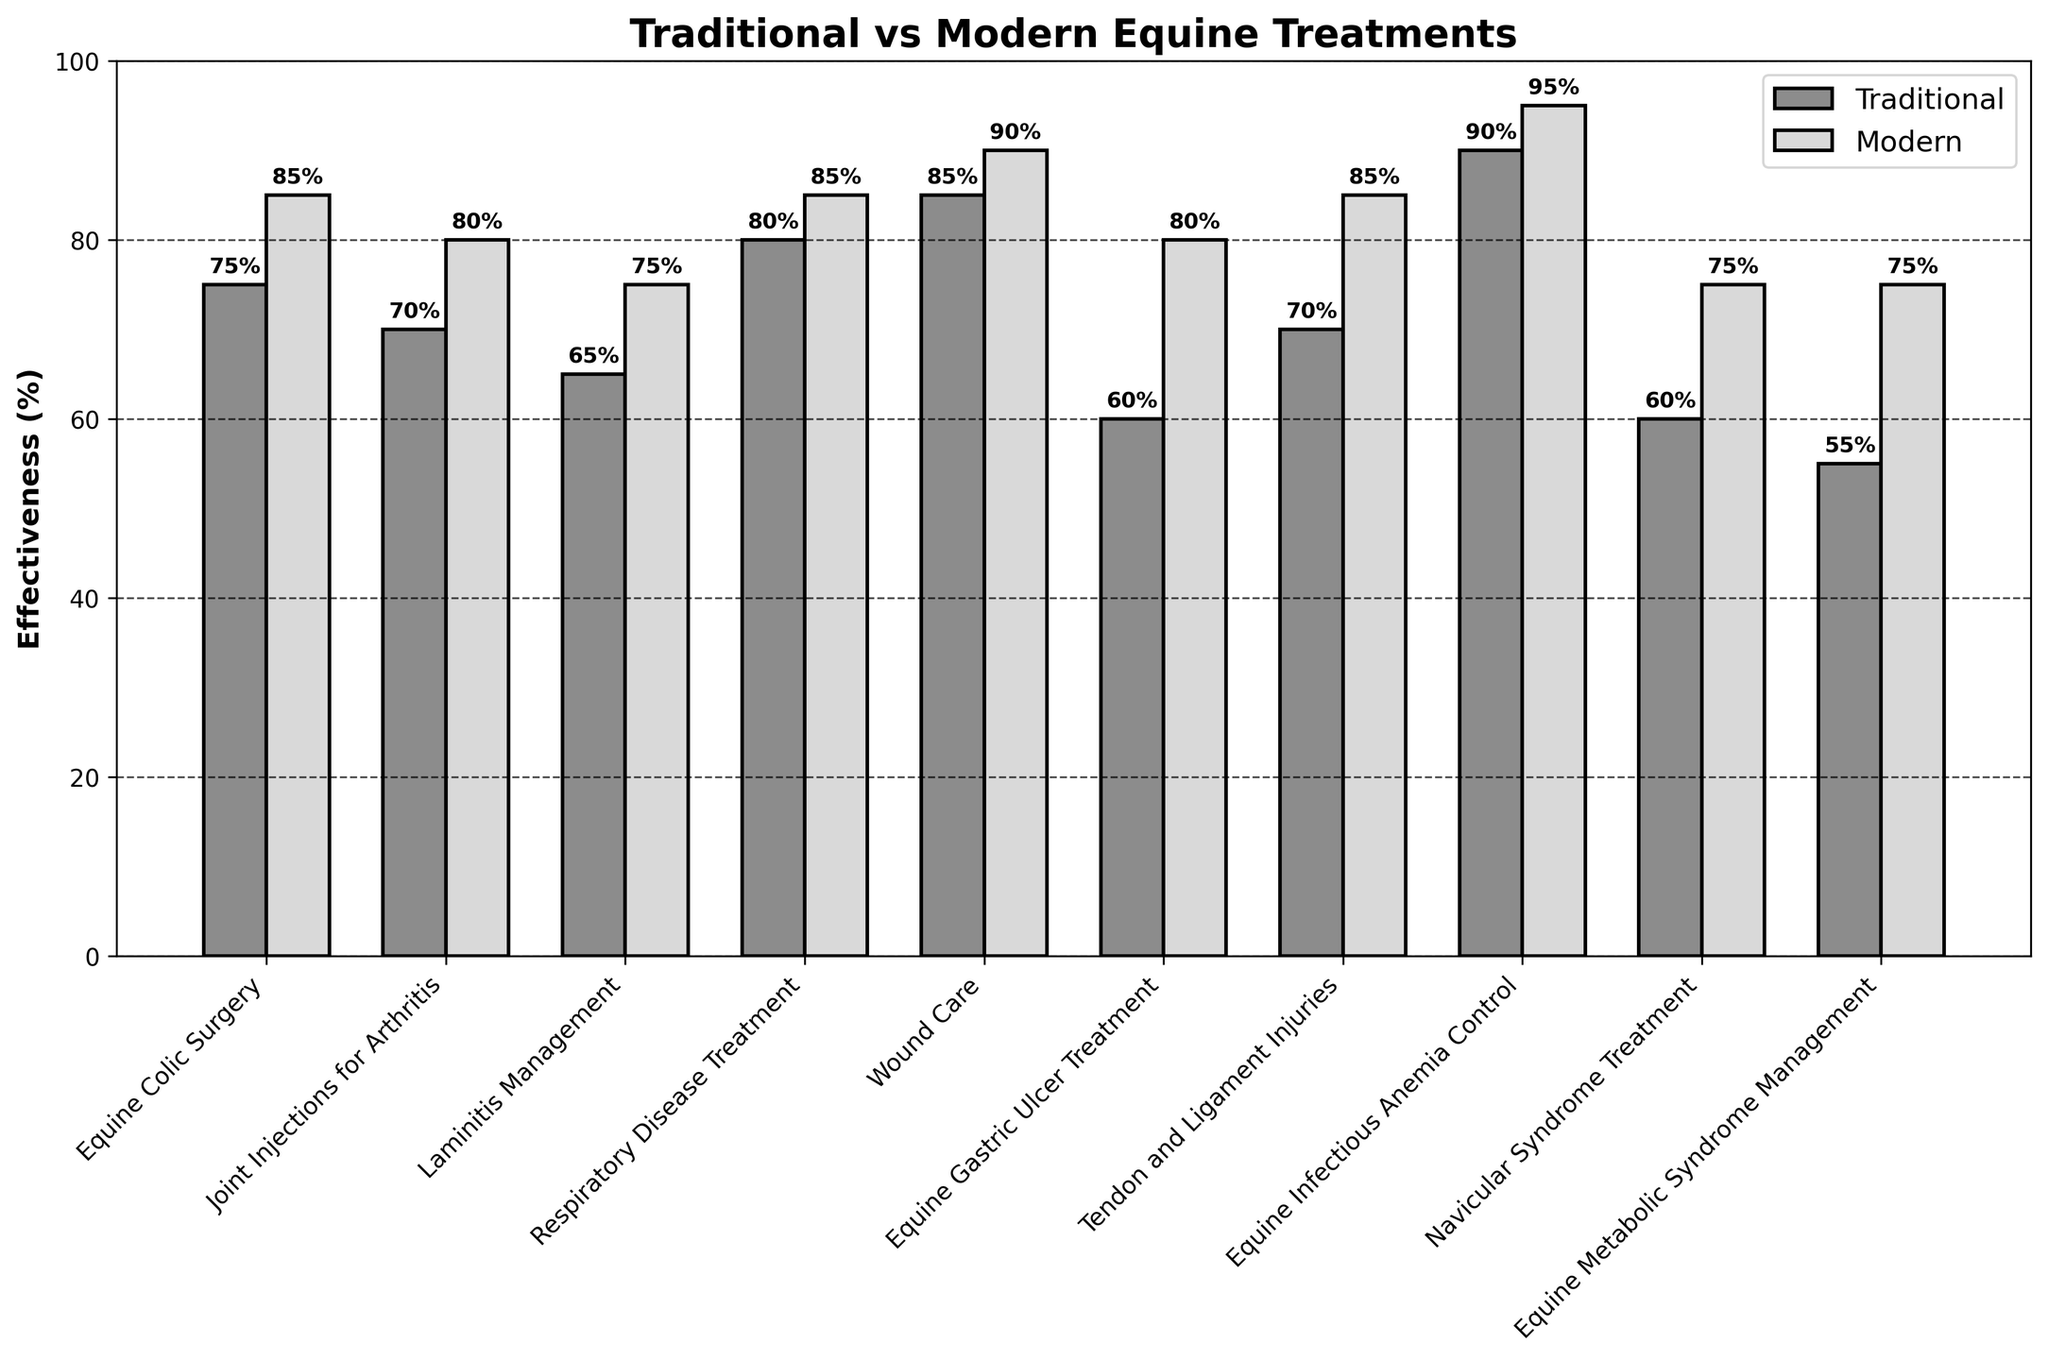What is the effectiveness rate of traditional respiratory disease treatment? Locate the bar corresponding to traditional respiratory disease treatment and read the percentage value from the y-axis.
Answer: 80% Which treatment shows the greatest difference in effectiveness between modern and traditional methods? Calculate the difference between traditional and modern effectiveness for each treatment, and identify the treatment with the largest difference. For example, Equine Gastric Ulcer Treatment has traditional effectiveness of 60% and modern effectiveness of 80%, giving a difference of 20%.
Answer: Equine Gastric Ulcer Treatment Are traditional treatments ever more effective than modern treatments? Compare the height of the bars for each treatment; if the traditional bar height exceeds the modern bar height for any treatment, tradition is more effective.
Answer: No What is the average effectiveness rate of traditional treatments? Sum the effectiveness rates of all traditional treatments and divide by the number of treatments (10): (75 + 70 + 65 + 80 + 85 + 60 + 70 + 90 + 60 + 55) / 10 = 71%
Answer: 71% Which treatment has the lowest effectiveness rate for modern methods? Identify the shortest bar corresponding to the modern effectiveness rates and read its value.
Answer: Laminitis Management Calculate the mean difference in effectiveness between traditional and modern methods across all treatments. Calculate the differences for each treatment, sum them up, and divide by the number of treatments: ((85-75) + (80-70) + (75-65) + (85-80) + (90-85) + (80-60) + (85-70) + (95-90) + (75-60) + (75-55)) / 10 = 9.5%.
Answer: 9.5% Which treatment areas have an effectiveness rate of 75% or higher for modern methods? Identify treatments where the modern effectiveness rate is 75% or higher: Equine Colic Surgery, Joint Injections for Arthritis, Laminitis Management, Respiratory Disease Treatment, Wound Care, Equine Gastric Ulcer Treatment, Tendon and Ligament Injuries, Equine Infectious Anemia Control, Navicular Syndrome Treatment, and Equine Metabolic Syndrome Management.
Answer: All How much more effective is modern wound care compared to traditional wound care? Subtract the traditional effectiveness rate of wound care from the modern effectiveness rate: 90% - 85% = 5%.
Answer: 5% What is the trend in effectiveness when comparing traditional to modern treatments? Compare each treatment pair's bars to see if modern treatments are generally higher than traditional treatments.
Answer: Modern treatments are generally more effective 